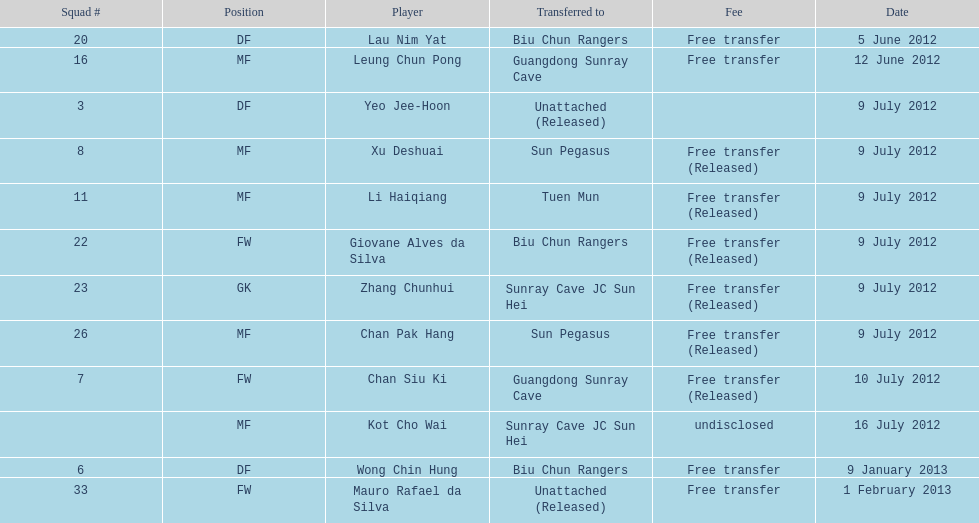Which team received lau nim yat and giovane alves de silva in a transfer? Biu Chun Rangers. 